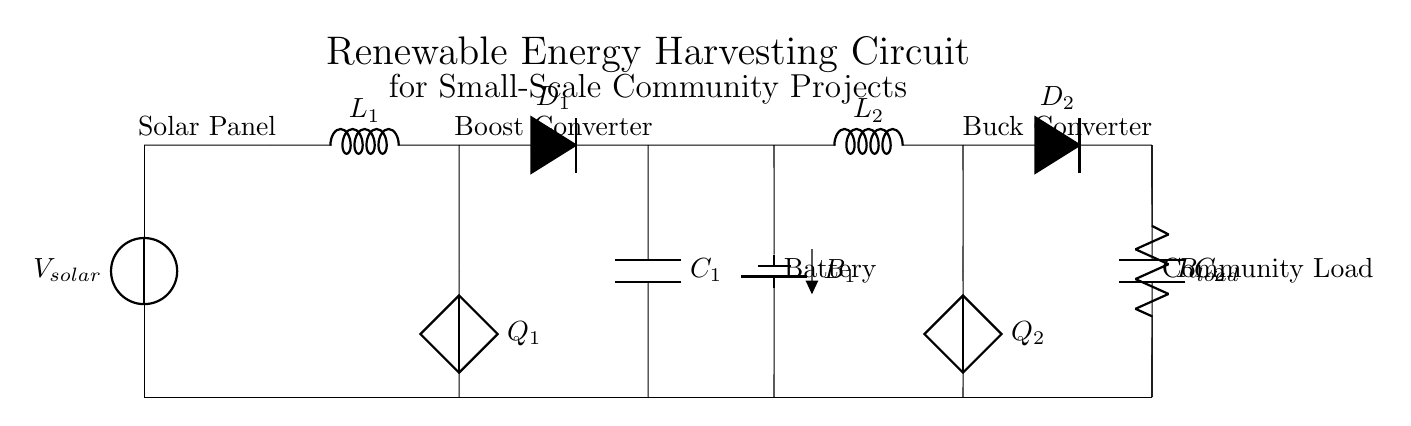What is the component for energy storage? The component designated for energy storage in the circuit is labeled as "Battery," which is indicated as B1.
Answer: Battery What type of converter is used to step up voltage? The circuit uses a "Boost Converter," specifically labeled as L1 and Q1, which increases the voltage from the solar panel.
Answer: Boost Converter What does R load represent in this circuit? R load is designated on the circuit as the load resistance, representing the electrical component or device that will consume power from the circuit.
Answer: Load How many diodes are present in the circuit? There are two diodes indicated in the circuit; these are labeled as D1 and D2, used for controlling the direction of current flow.
Answer: Two What is the purpose of C1 and C2? The components C1 and C2 represent capacitors that are used for filtering and smoothing voltage in the circuit after conversion processes.
Answer: Filtering capacitors Which energy source is represented at the beginning of the circuit? The circuit starts with a "Solar Panel," which converts sunlight into electrical energy, indicated as V solar.
Answer: Solar Panel What type of converter is used to step down voltage? The circuit includes a "Buck Converter," specifically labeled as L2 and Q2, which decreases the voltage for the load after being stored in the battery.
Answer: Buck Converter 